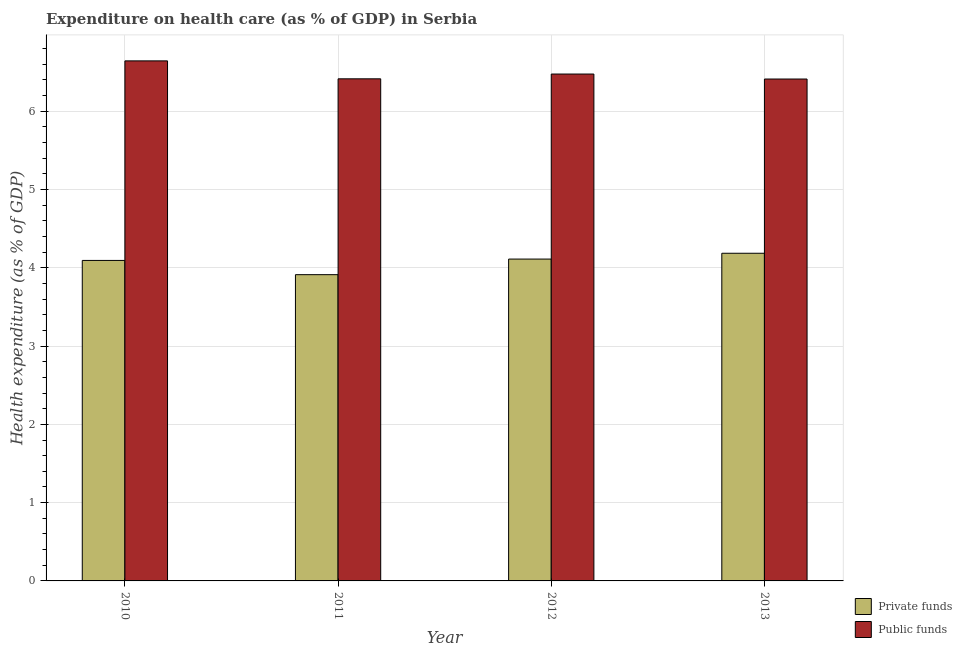How many groups of bars are there?
Your answer should be compact. 4. Are the number of bars per tick equal to the number of legend labels?
Give a very brief answer. Yes. How many bars are there on the 1st tick from the right?
Your answer should be very brief. 2. What is the label of the 2nd group of bars from the left?
Offer a terse response. 2011. In how many cases, is the number of bars for a given year not equal to the number of legend labels?
Ensure brevity in your answer.  0. What is the amount of public funds spent in healthcare in 2011?
Your response must be concise. 6.41. Across all years, what is the maximum amount of private funds spent in healthcare?
Your answer should be compact. 4.19. Across all years, what is the minimum amount of public funds spent in healthcare?
Your response must be concise. 6.41. In which year was the amount of private funds spent in healthcare maximum?
Make the answer very short. 2013. In which year was the amount of private funds spent in healthcare minimum?
Make the answer very short. 2011. What is the total amount of public funds spent in healthcare in the graph?
Ensure brevity in your answer.  25.94. What is the difference between the amount of public funds spent in healthcare in 2010 and that in 2013?
Keep it short and to the point. 0.23. What is the difference between the amount of private funds spent in healthcare in 2012 and the amount of public funds spent in healthcare in 2010?
Keep it short and to the point. 0.02. What is the average amount of private funds spent in healthcare per year?
Offer a very short reply. 4.08. In how many years, is the amount of private funds spent in healthcare greater than 1.4 %?
Your response must be concise. 4. What is the ratio of the amount of public funds spent in healthcare in 2010 to that in 2012?
Provide a succinct answer. 1.03. What is the difference between the highest and the second highest amount of private funds spent in healthcare?
Provide a short and direct response. 0.07. What is the difference between the highest and the lowest amount of private funds spent in healthcare?
Your response must be concise. 0.27. In how many years, is the amount of private funds spent in healthcare greater than the average amount of private funds spent in healthcare taken over all years?
Provide a short and direct response. 3. Is the sum of the amount of private funds spent in healthcare in 2011 and 2013 greater than the maximum amount of public funds spent in healthcare across all years?
Your answer should be compact. Yes. What does the 1st bar from the left in 2011 represents?
Offer a terse response. Private funds. What does the 1st bar from the right in 2011 represents?
Keep it short and to the point. Public funds. How many bars are there?
Provide a succinct answer. 8. How many years are there in the graph?
Give a very brief answer. 4. What is the difference between two consecutive major ticks on the Y-axis?
Make the answer very short. 1. Does the graph contain any zero values?
Provide a succinct answer. No. Does the graph contain grids?
Offer a very short reply. Yes. How many legend labels are there?
Keep it short and to the point. 2. What is the title of the graph?
Offer a very short reply. Expenditure on health care (as % of GDP) in Serbia. What is the label or title of the Y-axis?
Your answer should be very brief. Health expenditure (as % of GDP). What is the Health expenditure (as % of GDP) of Private funds in 2010?
Give a very brief answer. 4.09. What is the Health expenditure (as % of GDP) of Public funds in 2010?
Your answer should be very brief. 6.64. What is the Health expenditure (as % of GDP) of Private funds in 2011?
Ensure brevity in your answer.  3.91. What is the Health expenditure (as % of GDP) of Public funds in 2011?
Give a very brief answer. 6.41. What is the Health expenditure (as % of GDP) in Private funds in 2012?
Keep it short and to the point. 4.11. What is the Health expenditure (as % of GDP) in Public funds in 2012?
Your response must be concise. 6.48. What is the Health expenditure (as % of GDP) in Private funds in 2013?
Your answer should be very brief. 4.19. What is the Health expenditure (as % of GDP) in Public funds in 2013?
Provide a succinct answer. 6.41. Across all years, what is the maximum Health expenditure (as % of GDP) of Private funds?
Give a very brief answer. 4.19. Across all years, what is the maximum Health expenditure (as % of GDP) of Public funds?
Your response must be concise. 6.64. Across all years, what is the minimum Health expenditure (as % of GDP) in Private funds?
Offer a very short reply. 3.91. Across all years, what is the minimum Health expenditure (as % of GDP) of Public funds?
Keep it short and to the point. 6.41. What is the total Health expenditure (as % of GDP) of Private funds in the graph?
Keep it short and to the point. 16.3. What is the total Health expenditure (as % of GDP) in Public funds in the graph?
Provide a succinct answer. 25.94. What is the difference between the Health expenditure (as % of GDP) of Private funds in 2010 and that in 2011?
Your response must be concise. 0.18. What is the difference between the Health expenditure (as % of GDP) in Public funds in 2010 and that in 2011?
Ensure brevity in your answer.  0.23. What is the difference between the Health expenditure (as % of GDP) of Private funds in 2010 and that in 2012?
Ensure brevity in your answer.  -0.02. What is the difference between the Health expenditure (as % of GDP) in Public funds in 2010 and that in 2012?
Provide a short and direct response. 0.17. What is the difference between the Health expenditure (as % of GDP) of Private funds in 2010 and that in 2013?
Provide a short and direct response. -0.09. What is the difference between the Health expenditure (as % of GDP) of Public funds in 2010 and that in 2013?
Your answer should be very brief. 0.23. What is the difference between the Health expenditure (as % of GDP) of Private funds in 2011 and that in 2012?
Offer a terse response. -0.2. What is the difference between the Health expenditure (as % of GDP) in Public funds in 2011 and that in 2012?
Provide a short and direct response. -0.06. What is the difference between the Health expenditure (as % of GDP) in Private funds in 2011 and that in 2013?
Ensure brevity in your answer.  -0.27. What is the difference between the Health expenditure (as % of GDP) in Public funds in 2011 and that in 2013?
Your answer should be very brief. 0. What is the difference between the Health expenditure (as % of GDP) of Private funds in 2012 and that in 2013?
Ensure brevity in your answer.  -0.07. What is the difference between the Health expenditure (as % of GDP) of Public funds in 2012 and that in 2013?
Your answer should be very brief. 0.06. What is the difference between the Health expenditure (as % of GDP) in Private funds in 2010 and the Health expenditure (as % of GDP) in Public funds in 2011?
Make the answer very short. -2.32. What is the difference between the Health expenditure (as % of GDP) of Private funds in 2010 and the Health expenditure (as % of GDP) of Public funds in 2012?
Your answer should be compact. -2.38. What is the difference between the Health expenditure (as % of GDP) of Private funds in 2010 and the Health expenditure (as % of GDP) of Public funds in 2013?
Offer a very short reply. -2.32. What is the difference between the Health expenditure (as % of GDP) in Private funds in 2011 and the Health expenditure (as % of GDP) in Public funds in 2012?
Provide a succinct answer. -2.56. What is the difference between the Health expenditure (as % of GDP) in Private funds in 2011 and the Health expenditure (as % of GDP) in Public funds in 2013?
Offer a very short reply. -2.5. What is the difference between the Health expenditure (as % of GDP) in Private funds in 2012 and the Health expenditure (as % of GDP) in Public funds in 2013?
Provide a short and direct response. -2.3. What is the average Health expenditure (as % of GDP) in Private funds per year?
Ensure brevity in your answer.  4.08. What is the average Health expenditure (as % of GDP) in Public funds per year?
Make the answer very short. 6.49. In the year 2010, what is the difference between the Health expenditure (as % of GDP) of Private funds and Health expenditure (as % of GDP) of Public funds?
Provide a succinct answer. -2.55. In the year 2011, what is the difference between the Health expenditure (as % of GDP) of Private funds and Health expenditure (as % of GDP) of Public funds?
Your answer should be very brief. -2.5. In the year 2012, what is the difference between the Health expenditure (as % of GDP) in Private funds and Health expenditure (as % of GDP) in Public funds?
Ensure brevity in your answer.  -2.36. In the year 2013, what is the difference between the Health expenditure (as % of GDP) in Private funds and Health expenditure (as % of GDP) in Public funds?
Your answer should be very brief. -2.23. What is the ratio of the Health expenditure (as % of GDP) in Private funds in 2010 to that in 2011?
Your answer should be compact. 1.05. What is the ratio of the Health expenditure (as % of GDP) of Public funds in 2010 to that in 2011?
Provide a short and direct response. 1.04. What is the ratio of the Health expenditure (as % of GDP) in Private funds in 2010 to that in 2012?
Offer a terse response. 1. What is the ratio of the Health expenditure (as % of GDP) in Public funds in 2010 to that in 2012?
Offer a terse response. 1.03. What is the ratio of the Health expenditure (as % of GDP) of Private funds in 2010 to that in 2013?
Provide a short and direct response. 0.98. What is the ratio of the Health expenditure (as % of GDP) of Public funds in 2010 to that in 2013?
Your answer should be compact. 1.04. What is the ratio of the Health expenditure (as % of GDP) in Private funds in 2011 to that in 2012?
Your answer should be very brief. 0.95. What is the ratio of the Health expenditure (as % of GDP) of Public funds in 2011 to that in 2012?
Offer a terse response. 0.99. What is the ratio of the Health expenditure (as % of GDP) of Private funds in 2011 to that in 2013?
Your response must be concise. 0.93. What is the ratio of the Health expenditure (as % of GDP) in Private funds in 2012 to that in 2013?
Ensure brevity in your answer.  0.98. What is the ratio of the Health expenditure (as % of GDP) of Public funds in 2012 to that in 2013?
Ensure brevity in your answer.  1.01. What is the difference between the highest and the second highest Health expenditure (as % of GDP) of Private funds?
Keep it short and to the point. 0.07. What is the difference between the highest and the second highest Health expenditure (as % of GDP) of Public funds?
Offer a terse response. 0.17. What is the difference between the highest and the lowest Health expenditure (as % of GDP) of Private funds?
Your answer should be very brief. 0.27. What is the difference between the highest and the lowest Health expenditure (as % of GDP) in Public funds?
Make the answer very short. 0.23. 